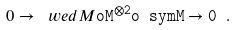Convert formula to latex. <formula><loc_0><loc_0><loc_500><loc_500>0 \to \ w e d { M } \tt o M ^ { \otimes 2 } \tt o \ s y m { M } \to 0 \ .</formula> 